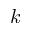Convert formula to latex. <formula><loc_0><loc_0><loc_500><loc_500>k</formula> 